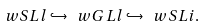Convert formula to latex. <formula><loc_0><loc_0><loc_500><loc_500>\ w S L l \hookrightarrow \ w G L l \hookrightarrow \ w S L i .</formula> 